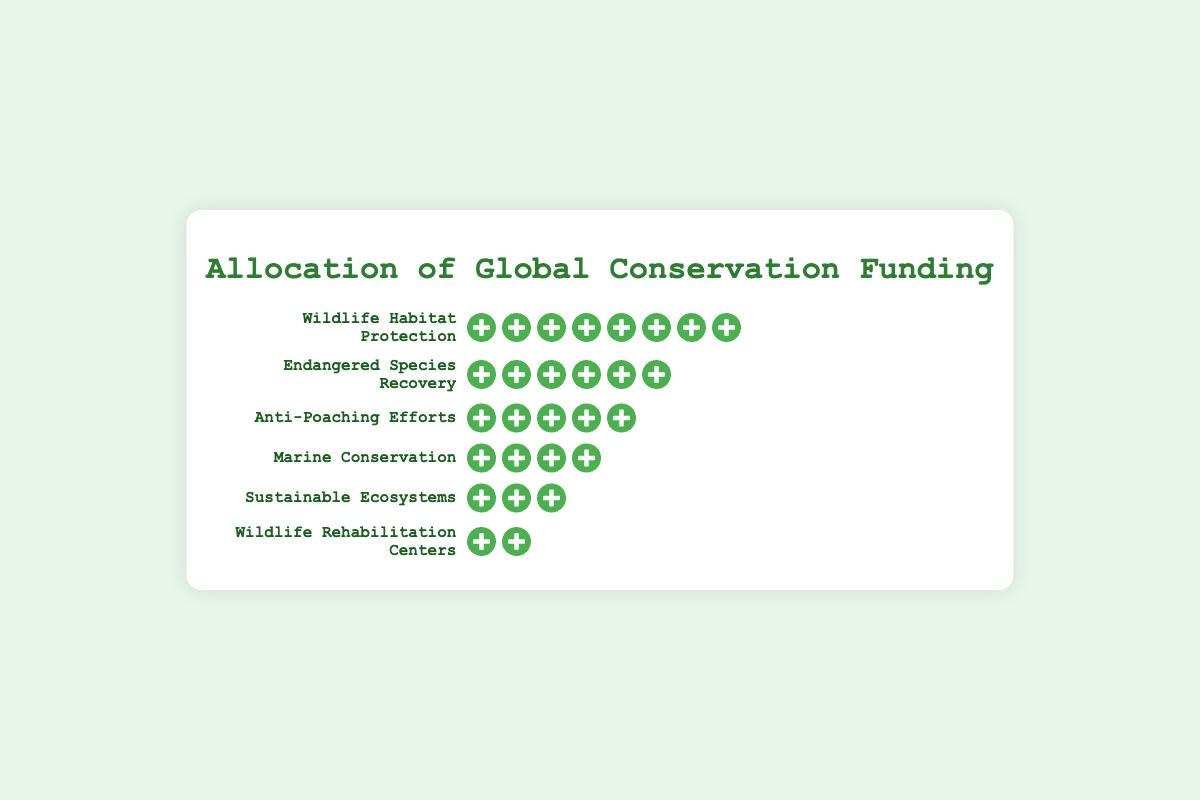What does the title of the figure say? The title of the figure is located at the top and provides a summarizing explanation of what the figure represents. The title in the provided figure text is "Allocation of Global Conservation Funding."
Answer: Allocation of Global Conservation Funding Which conservation initiative receives the most funding? By observing the number of icons representing funding units for each initiative, the one with the most icons indicates the highest funding. Wildlife Habitat Protection has 8 icons, the largest number in the figure.
Answer: Wildlife Habitat Protection How many funding units are allocated to Marine Conservation? Each icon represents one funding unit. By counting the icons next to Marine Conservation, we find four icons.
Answer: 4 How many more funding units does Endangered Species Recovery receive compared to Sustainable Ecosystems? Endangered Species Recovery has 6 icons and Sustainable Ecosystems has 3 icons. The difference in funding units is 6 - 3.
Answer: 3 Which conservation initiative receives the least funding? The initiative with the fewest icons (funding units) receives the least funding. Wildlife Rehabilitation Centers have 2 icons, which is the smallest number shown.
Answer: Wildlife Rehabilitation Centers What is the total number of funding units allocated across all initiatives? Sum the number of icons for each conservation initiative: 8 (Wildlife Habitat Protection) + 6 (Endangered Species Recovery) + 5 (Anti-Poaching Efforts) + 4 (Marine Conservation) + 3 (Sustainable Ecosystems) + 2 (Wildlife Rehabilitation Centers).
Answer: 28 How does the funding for Anti-Poaching Efforts compare to Marine Conservation? Anti-Poaching Efforts have 5 icons, while Marine Conservation has 4 icons. Since 5 is greater than 4, Anti-Poaching Efforts receive more funding.
Answer: Anti-Poaching Efforts receive more funding If funding for Sustainable Ecosystems were doubled, how many units of funding would it receive? Currently, Sustainable Ecosystems have 3 icons. Doubling this amount means 3 x 2.
Answer: 6 What proportion of the total funding is allocated to Wildlife Habitat Protection? Wildlife Habitat Protection has 8 icons. The total number of icons is 28. The proportion is calculated as 8/28. Simplified, this fraction is approximately 0.286 or 28.6%.
Answer: 28.6% What is the combined funding of Anti-Poaching Efforts and Wildlife Rehabilitation Centers? Anti-Poaching Efforts have 5 icons and Wildlife Rehabilitation Centers have 2 icons. Adding these gives 5 + 2.
Answer: 7 